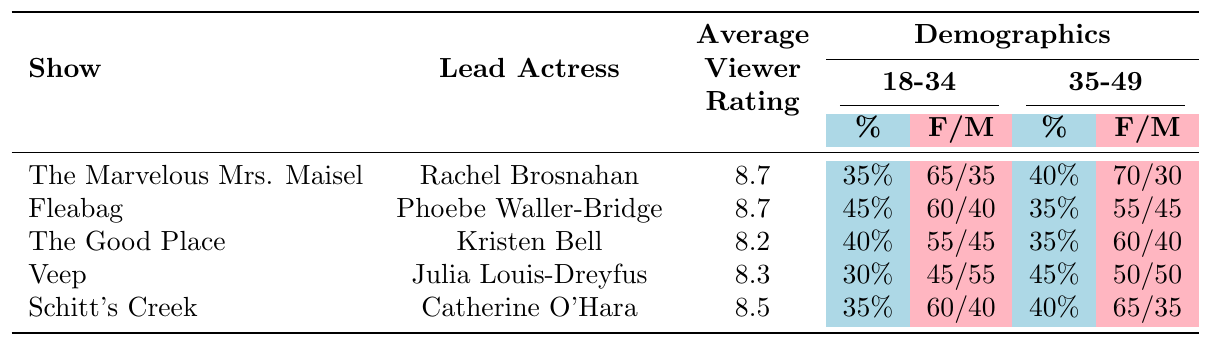What is the average viewer rating for "The Good Place"? The average viewer rating for "The Good Place," according to the table, is directly listed as 8.2.
Answer: 8.2 Which show has the highest percentage of female viewers in the 18-34 age group? Looking at the demographic data for the 18-34 age group, "Fleabag" has the highest percentage of female viewers at 60%.
Answer: Fleabag Is the average viewer rating for "Schitt's Creek" higher than that of "Veep"? Comparing the average viewer ratings, "Schitt's Creek" has a rating of 8.5, while "Veep" has a rating of 8.3. Since 8.5 is greater than 8.3, the answer is yes.
Answer: Yes What is the gender split for the 35-49 age group viewers of "The Marvelous Mrs. Maisel"? The table shows that in the 35-49 age group for "The Marvelous Mrs. Maisel," the gender split is 70% female and 30% male.
Answer: 70/30 Which show has the lowest average viewer rating, and what is that rating? By examining the average viewer ratings, "The Good Place" has the lowest rating at 8.2 compared to the others, which are higher.
Answer: The Good Place, 8.2 How does the percentage of female viewers in the 35-49 age group for "Schitt's Creek" compare to that of "The Good Place"? For "Schitt's Creek," the female viewer percentage in the 35-49 age group is 65%, while for "The Good Place" it is 60%. Since 65% is greater than 60%, Schitt's Creek has a higher percentage of female viewers in this age group.
Answer: Schitt's Creek has a higher percentage What is the total percentage of viewers aged 50 and above for "Veep"? In the case of "Veep," the table shows that the percentage of viewers aged 50 and above is 25%.
Answer: 25% Which show has a higher average rating, "Fleabag" or "The Marvelous Mrs. Maisel"? Both "Fleabag" and "The Marvelous Mrs. Maisel" have the same average viewer rating of 8.7, so they are equal.
Answer: They are equal (8.7) For the 50+ age group, which show has more male viewers in percentage terms, "Fleabag" or "Veep"? In the 50+ age group, "Fleabag" shows a 50% male viewership, while "Veep" shows a 45% male viewership. Since 50% is greater, "Fleabag" has more male viewers.
Answer: Fleabag Looking at the 18-34 age group, what is the difference in percentage of male viewers between "Veep" and "The Good Place"? "Veep" has a male viewership of 55% in the 18-34 age group, while "The Good Place" has 45%. The difference is 55% - 45% = 10%.
Answer: 10% In terms of demographics, which show has a more diverse range of viewers based on a significant female percentage across different age groups? "The Marvelous Mrs. Maisel" has the highest consistent female percentages across all age groups: 65%, 70%, and 60% for 18-34, 35-49, and 50+ respectively, indicating a broader female appeal.
Answer: The Marvelous Mrs. Maisel has a more diverse range 